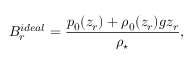<formula> <loc_0><loc_0><loc_500><loc_500>B _ { r } ^ { i d e a l } = \frac { p _ { 0 } ( z _ { r } ) + \rho _ { 0 } ( z _ { r } ) g z _ { r } } { \rho _ { ^ { * } } } ,</formula> 